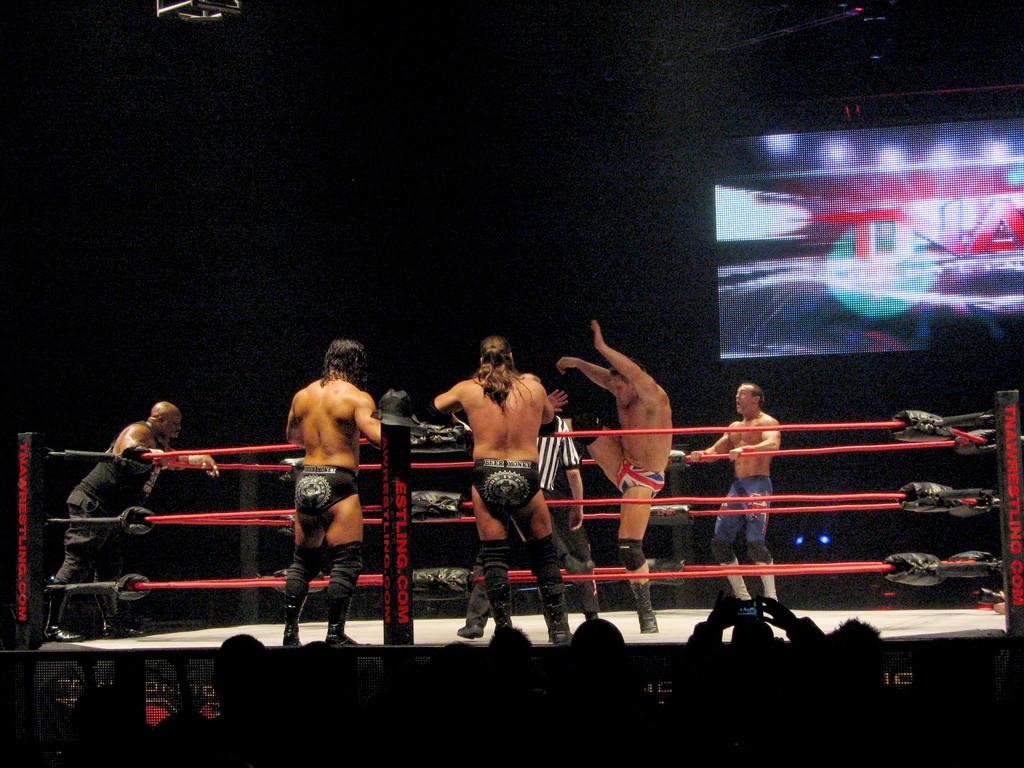What is the website given on the ring?
Provide a short and direct response. Estling.com. 